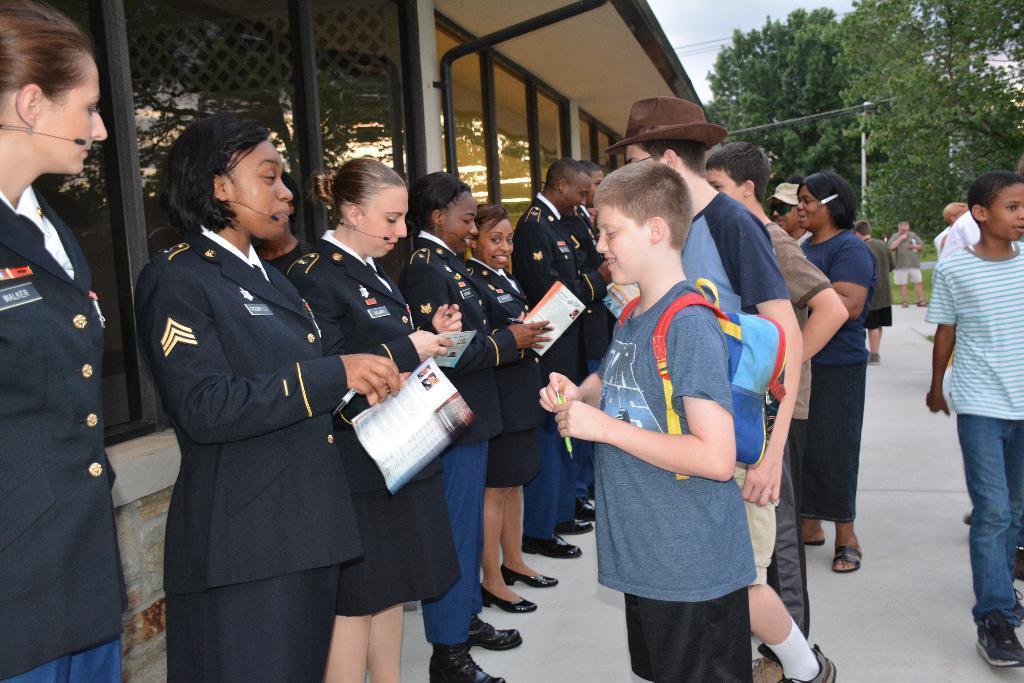Could you give a brief overview of what you see in this image? In the image there are many women in uniform standing in the front holding books, there are few kids standing in front of them, on the left side there is a building and on the right side there are trees. 